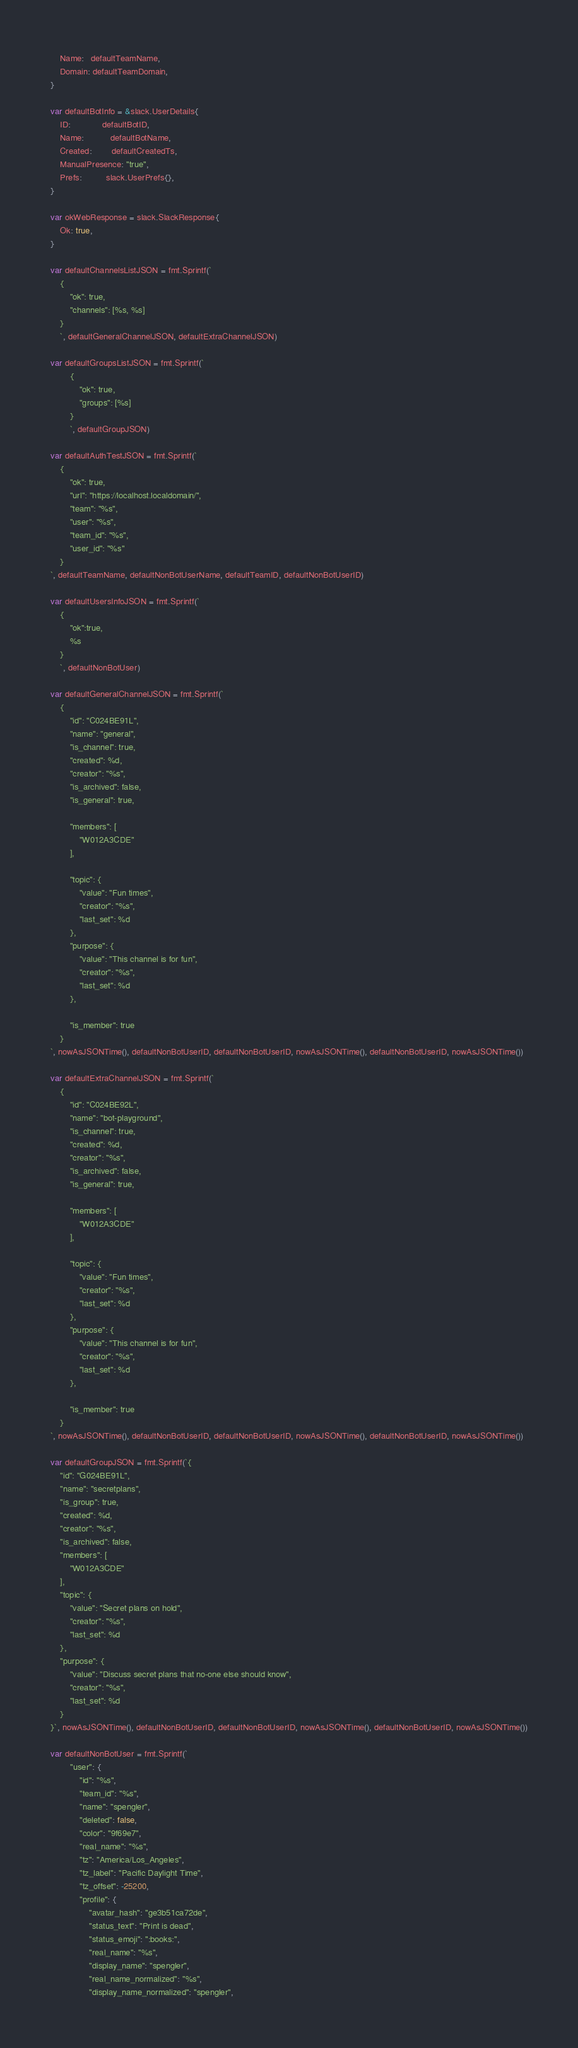<code> <loc_0><loc_0><loc_500><loc_500><_Go_>	Name:   defaultTeamName,
	Domain: defaultTeamDomain,
}

var defaultBotInfo = &slack.UserDetails{
	ID:             defaultBotID,
	Name:           defaultBotName,
	Created:        defaultCreatedTs,
	ManualPresence: "true",
	Prefs:          slack.UserPrefs{},
}

var okWebResponse = slack.SlackResponse{
	Ok: true,
}

var defaultChannelsListJSON = fmt.Sprintf(`
	{
		"ok": true,
		"channels": [%s, %s]
	}
	`, defaultGeneralChannelJSON, defaultExtraChannelJSON)

var defaultGroupsListJSON = fmt.Sprintf(`
		{
			"ok": true,
			"groups": [%s]
		}
		`, defaultGroupJSON)

var defaultAuthTestJSON = fmt.Sprintf(`
	{
		"ok": true,
		"url": "https://localhost.localdomain/",
		"team": "%s",
		"user": "%s",
		"team_id": "%s",
		"user_id": "%s"
	}
`, defaultTeamName, defaultNonBotUserName, defaultTeamID, defaultNonBotUserID)

var defaultUsersInfoJSON = fmt.Sprintf(`
	{
		"ok":true,
		%s
	}
	`, defaultNonBotUser)

var defaultGeneralChannelJSON = fmt.Sprintf(`
	{
        "id": "C024BE91L",
        "name": "general",
        "is_channel": true,
        "created": %d,
        "creator": "%s",
        "is_archived": false,
        "is_general": true,

        "members": [
            "W012A3CDE"
        ],

        "topic": {
            "value": "Fun times",
            "creator": "%s",
            "last_set": %d
        },
        "purpose": {
            "value": "This channel is for fun",
            "creator": "%s",
            "last_set": %d
        },

        "is_member": true
    }
`, nowAsJSONTime(), defaultNonBotUserID, defaultNonBotUserID, nowAsJSONTime(), defaultNonBotUserID, nowAsJSONTime())

var defaultExtraChannelJSON = fmt.Sprintf(`
	{
        "id": "C024BE92L",
        "name": "bot-playground",
        "is_channel": true,
        "created": %d,
        "creator": "%s",
        "is_archived": false,
        "is_general": true,

        "members": [
            "W012A3CDE"
        ],

        "topic": {
            "value": "Fun times",
            "creator": "%s",
            "last_set": %d
        },
        "purpose": {
            "value": "This channel is for fun",
            "creator": "%s",
            "last_set": %d
        },

        "is_member": true
    }
`, nowAsJSONTime(), defaultNonBotUserID, defaultNonBotUserID, nowAsJSONTime(), defaultNonBotUserID, nowAsJSONTime())

var defaultGroupJSON = fmt.Sprintf(`{
    "id": "G024BE91L",
    "name": "secretplans",
    "is_group": true,
    "created": %d,
    "creator": "%s",
    "is_archived": false,
    "members": [
        "W012A3CDE"
    ],
    "topic": {
        "value": "Secret plans on hold",
        "creator": "%s",
        "last_set": %d
    },
    "purpose": {
        "value": "Discuss secret plans that no-one else should know",
        "creator": "%s",
        "last_set": %d
    }
}`, nowAsJSONTime(), defaultNonBotUserID, defaultNonBotUserID, nowAsJSONTime(), defaultNonBotUserID, nowAsJSONTime())

var defaultNonBotUser = fmt.Sprintf(`
		"user": {
			"id": "%s",
			"team_id": "%s",
			"name": "spengler",
			"deleted": false,
			"color": "9f69e7",
			"real_name": "%s",
			"tz": "America/Los_Angeles",
			"tz_label": "Pacific Daylight Time",
			"tz_offset": -25200,
			"profile": {
				"avatar_hash": "ge3b51ca72de",
				"status_text": "Print is dead",
				"status_emoji": ":books:",
				"real_name": "%s",
				"display_name": "spengler",
				"real_name_normalized": "%s",
				"display_name_normalized": "spengler",</code> 